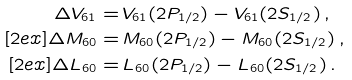<formula> <loc_0><loc_0><loc_500><loc_500>\Delta V _ { 6 1 } = & \, V _ { 6 1 } ( 2 P _ { 1 / 2 } ) - V _ { 6 1 } ( 2 S _ { 1 / 2 } ) \, , \\ [ 2 e x ] \Delta M _ { 6 0 } = & \, M _ { 6 0 } ( 2 P _ { 1 / 2 } ) - M _ { 6 0 } ( 2 S _ { 1 / 2 } ) \, , \\ [ 2 e x ] \Delta L _ { 6 0 } = & \, L _ { 6 0 } ( 2 P _ { 1 / 2 } ) - L _ { 6 0 } ( 2 S _ { 1 / 2 } ) \, .</formula> 